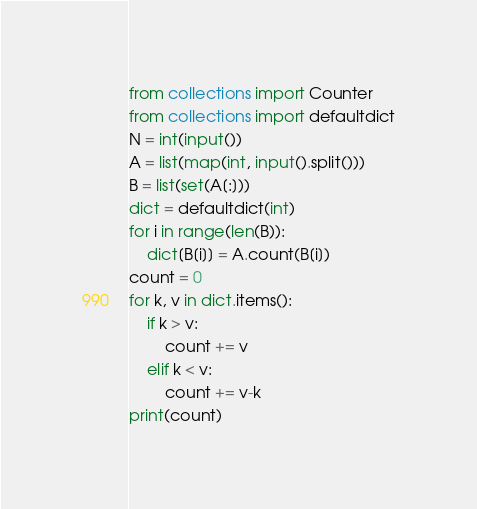<code> <loc_0><loc_0><loc_500><loc_500><_Python_>from collections import Counter
from collections import defaultdict
N = int(input())
A = list(map(int, input().split()))
B = list(set(A[:]))
dict = defaultdict(int)
for i in range(len(B)):
    dict[B[i]] = A.count(B[i])
count = 0
for k, v in dict.items():
    if k > v:
        count += v
    elif k < v:
        count += v-k
print(count)
</code> 